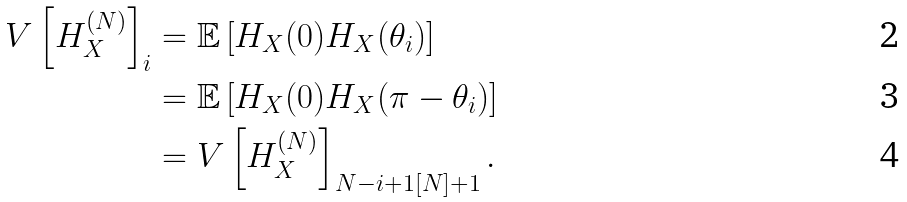<formula> <loc_0><loc_0><loc_500><loc_500>V \left [ H ^ { ( N ) } _ { X } \right ] _ { i } & = \mathbb { E } \left [ H _ { X } ( 0 ) H _ { X } ( \theta _ { i } ) \right ] \\ & = \mathbb { E } \left [ H _ { X } ( 0 ) H _ { X } ( \pi - \theta _ { i } ) \right ] \\ & = V \left [ H ^ { ( N ) } _ { X } \right ] _ { N - i + 1 [ N ] + 1 } .</formula> 